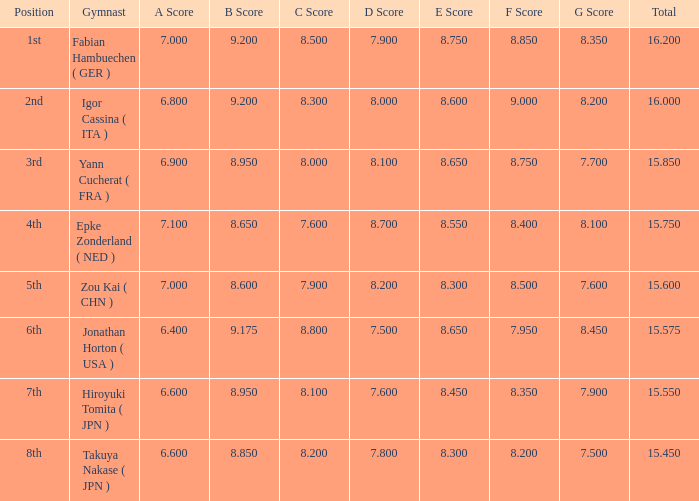Would you mind parsing the complete table? {'header': ['Position', 'Gymnast', 'A Score', 'B Score', 'C Score', 'D Score', 'E Score', 'F Score', 'G Score', 'Total'], 'rows': [['1st', 'Fabian Hambuechen ( GER )', '7.000', '9.200', '8.500', '7.900', '8.750', '8.850', '8.350', '16.200'], ['2nd', 'Igor Cassina ( ITA )', '6.800', '9.200', '8.300', '8.000', '8.600', '9.000', '8.200', '16.000'], ['3rd', 'Yann Cucherat ( FRA )', '6.900', '8.950', '8.000', '8.100', '8.650', '8.750', '7.700', '15.850'], ['4th', 'Epke Zonderland ( NED )', '7.100', '8.650', '7.600', '8.700', '8.550', '8.400', '8.100', '15.750'], ['5th', 'Zou Kai ( CHN )', '7.000', '8.600', '7.900', '8.200', '8.300', '8.500', '7.600', '15.600'], ['6th', 'Jonathan Horton ( USA )', '6.400', '9.175', '8.800', '7.500', '8.650', '7.950', '8.450', '15.575'], ['7th', 'Hiroyuki Tomita ( JPN )', '6.600', '8.950', '8.100', '7.600', '8.450', '8.350', '7.900', '15.550'], ['8th', 'Takuya Nakase ( JPN )', '6.600', '8.850', '8.200', '7.800', '8.300', '8.200', '7.500', '15.450']]} Which gymnast had a b score of 8.95 and an a score less than 6.9 Hiroyuki Tomita ( JPN ). 